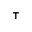<formula> <loc_0><loc_0><loc_500><loc_500>^ { \top }</formula> 